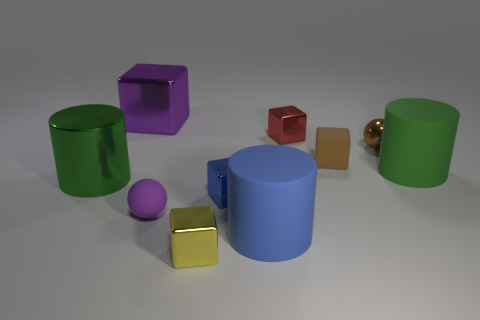There is a brown object on the left side of the small metallic ball; what material is it?
Offer a terse response. Rubber. Are there the same number of small purple objects that are on the right side of the blue metallic object and tiny yellow blocks?
Provide a succinct answer. No. Do the yellow thing and the green matte cylinder have the same size?
Offer a terse response. No. There is a blue cylinder that is to the left of the block to the right of the small red object; is there a small metal cube that is to the right of it?
Make the answer very short. Yes. There is a brown object that is the same shape as the tiny yellow thing; what is its material?
Your response must be concise. Rubber. There is a big metal thing in front of the tiny red block; how many large matte objects are in front of it?
Offer a terse response. 1. What is the size of the shiny thing that is in front of the small sphere in front of the object that is on the left side of the purple cube?
Provide a succinct answer. Small. What color is the matte cylinder that is in front of the green cylinder on the left side of the brown metallic sphere?
Offer a terse response. Blue. What number of other objects are there of the same material as the blue block?
Your answer should be very brief. 5. How many other objects are there of the same color as the metal ball?
Your answer should be compact. 1. 